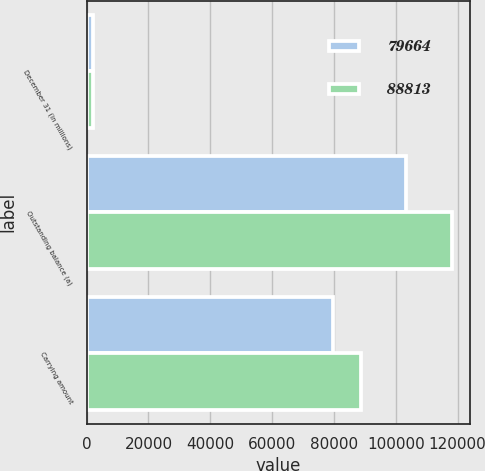Convert chart. <chart><loc_0><loc_0><loc_500><loc_500><stacked_bar_chart><ecel><fcel>December 31 (in millions)<fcel>Outstanding balance (a)<fcel>Carrying amount<nl><fcel>79664<fcel>2009<fcel>103369<fcel>79664<nl><fcel>88813<fcel>2008<fcel>118180<fcel>88813<nl></chart> 